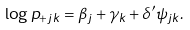<formula> <loc_0><loc_0><loc_500><loc_500>\log p _ { + j k } = \beta _ { j } + \gamma _ { k } + \delta ^ { \prime } \psi _ { j k } .</formula> 